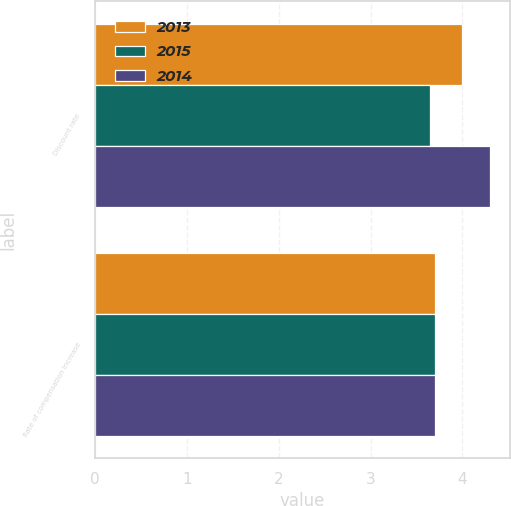Convert chart to OTSL. <chart><loc_0><loc_0><loc_500><loc_500><stacked_bar_chart><ecel><fcel>Discount rate<fcel>Rate of compensation increase<nl><fcel>2013<fcel>4<fcel>3.7<nl><fcel>2015<fcel>3.65<fcel>3.7<nl><fcel>2014<fcel>4.3<fcel>3.7<nl></chart> 